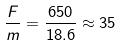<formula> <loc_0><loc_0><loc_500><loc_500>\frac { F } { m } = \frac { 6 5 0 } { 1 8 . 6 } \approx 3 5</formula> 